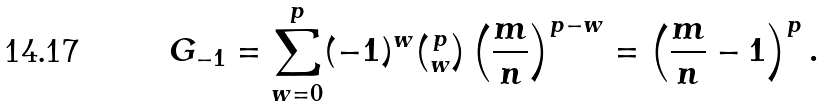<formula> <loc_0><loc_0><loc_500><loc_500>G _ { - 1 } = \sum _ { w = 0 } ^ { p } ( - 1 ) ^ { w } \tbinom p w \left ( \frac { m } { n } \right ) ^ { p - w } = \left ( \frac { m } { n } - 1 \right ) ^ { p } .</formula> 